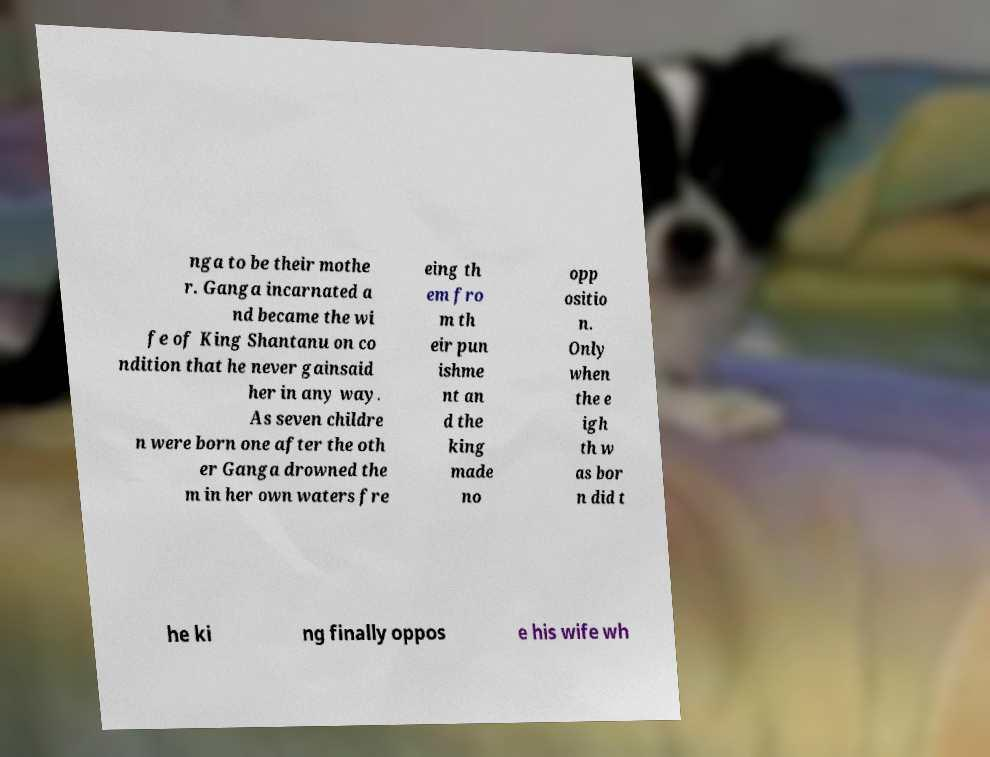There's text embedded in this image that I need extracted. Can you transcribe it verbatim? nga to be their mothe r. Ganga incarnated a nd became the wi fe of King Shantanu on co ndition that he never gainsaid her in any way. As seven childre n were born one after the oth er Ganga drowned the m in her own waters fre eing th em fro m th eir pun ishme nt an d the king made no opp ositio n. Only when the e igh th w as bor n did t he ki ng finally oppos e his wife wh 